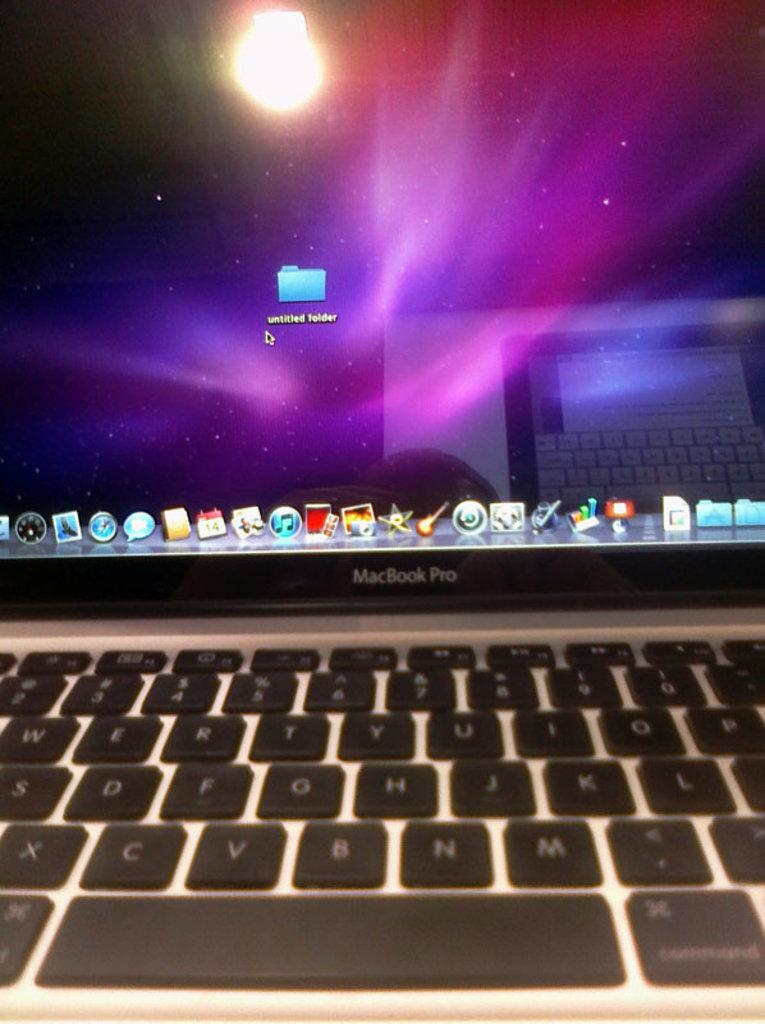<image>
Describe the image concisely. A MacBook Pro partially showing the keyboard with one untitled folder in the middle of the screen. 